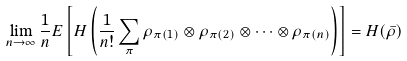<formula> <loc_0><loc_0><loc_500><loc_500>\lim _ { n \rightarrow \infty } \frac { 1 } { n } E \left [ H \left ( \frac { 1 } { n ! } \sum _ { \pi } \rho _ { \pi ( 1 ) } \otimes \rho _ { \pi ( 2 ) } \otimes \cdots \otimes \rho _ { \pi ( n ) } \right ) \right ] = H ( \bar { \rho } )</formula> 